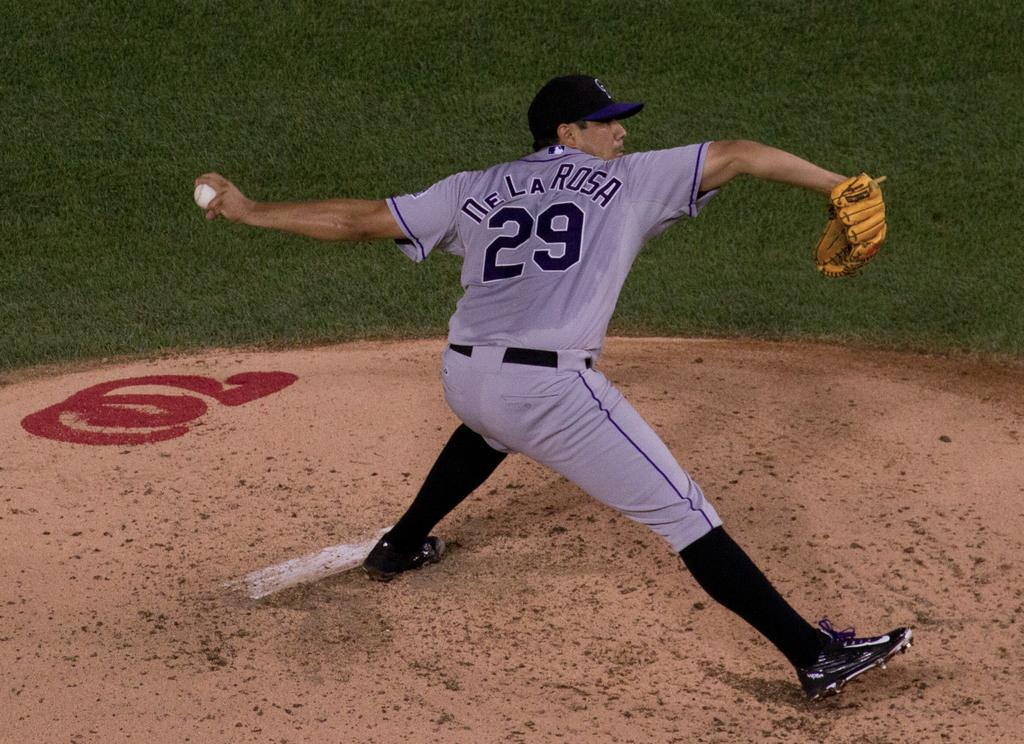<image>
Summarize the visual content of the image. Player number 29, De La Rosa is shown right as he is pitching the ball out on the field. 